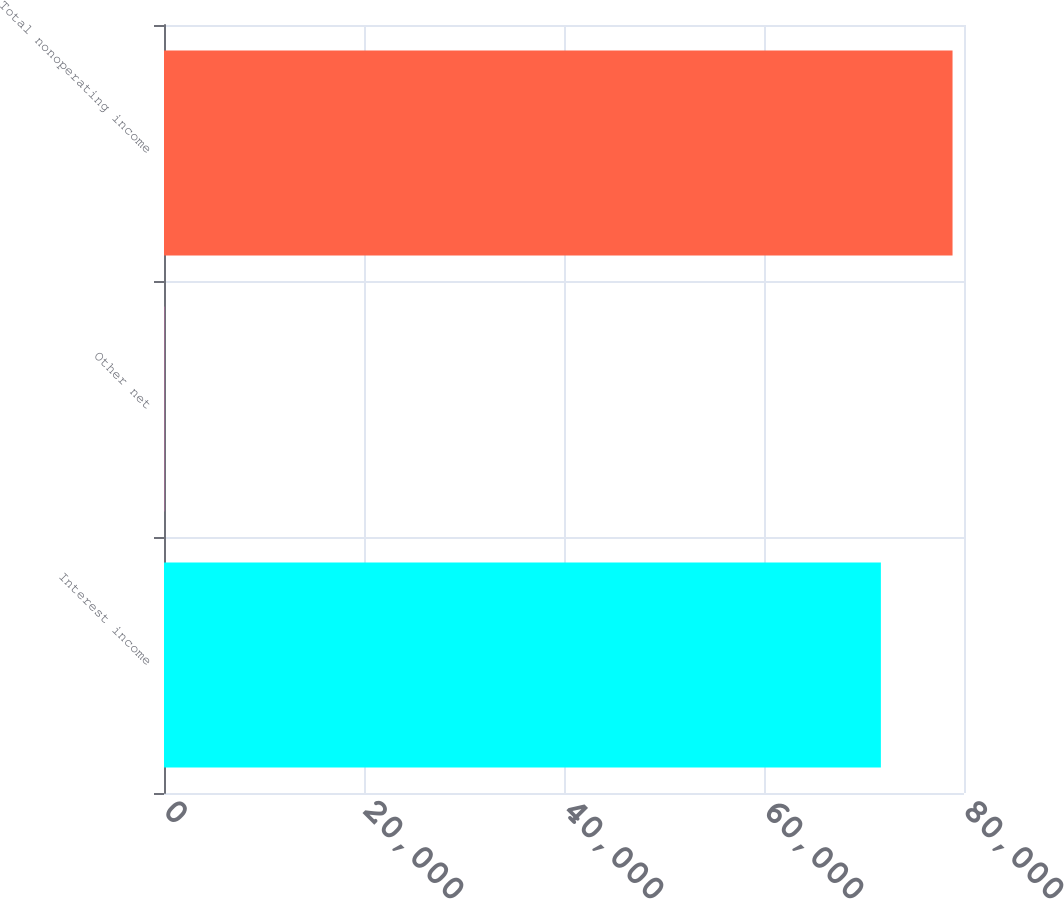Convert chart to OTSL. <chart><loc_0><loc_0><loc_500><loc_500><bar_chart><fcel>Interest income<fcel>Other net<fcel>Total nonoperating income<nl><fcel>71688<fcel>42<fcel>78854.1<nl></chart> 